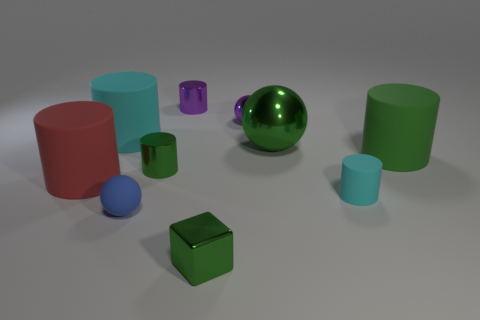Subtract all red cylinders. How many cylinders are left? 5 Subtract all small cyan matte cylinders. How many cylinders are left? 5 Subtract all yellow cylinders. Subtract all gray balls. How many cylinders are left? 6 Subtract all blocks. How many objects are left? 9 Subtract 1 red cylinders. How many objects are left? 9 Subtract all large metal spheres. Subtract all big matte things. How many objects are left? 6 Add 6 green metallic cylinders. How many green metallic cylinders are left? 7 Add 8 gray matte cylinders. How many gray matte cylinders exist? 8 